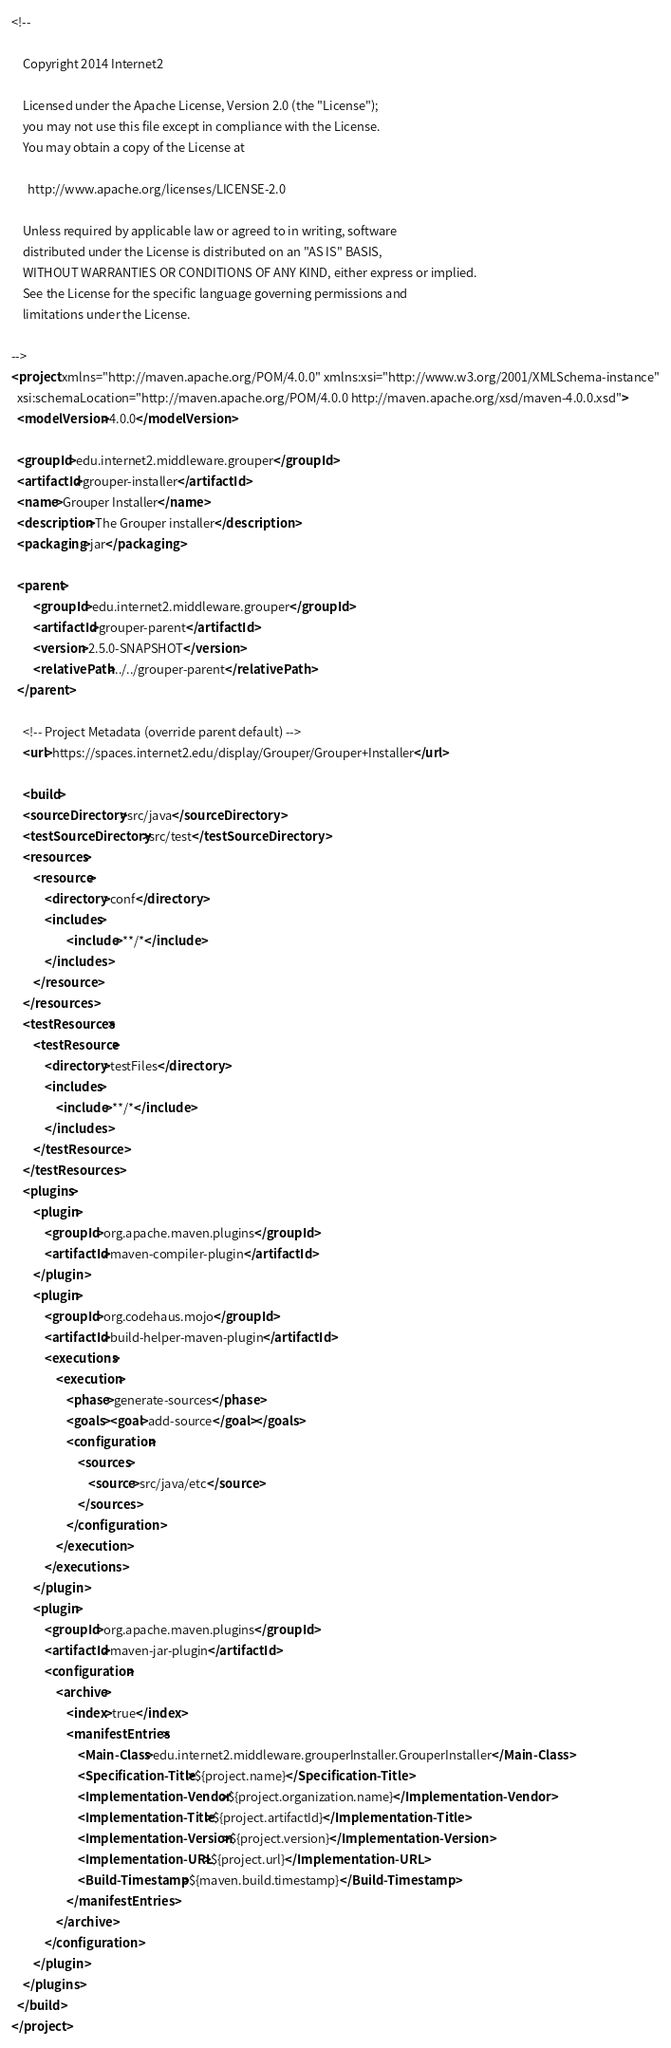Convert code to text. <code><loc_0><loc_0><loc_500><loc_500><_XML_><!--

    Copyright 2014 Internet2

    Licensed under the Apache License, Version 2.0 (the "License");
    you may not use this file except in compliance with the License.
    You may obtain a copy of the License at

      http://www.apache.org/licenses/LICENSE-2.0

    Unless required by applicable law or agreed to in writing, software
    distributed under the License is distributed on an "AS IS" BASIS,
    WITHOUT WARRANTIES OR CONDITIONS OF ANY KIND, either express or implied.
    See the License for the specific language governing permissions and
    limitations under the License.

-->
<project xmlns="http://maven.apache.org/POM/4.0.0" xmlns:xsi="http://www.w3.org/2001/XMLSchema-instance"
  xsi:schemaLocation="http://maven.apache.org/POM/4.0.0 http://maven.apache.org/xsd/maven-4.0.0.xsd">
  <modelVersion>4.0.0</modelVersion>

  <groupId>edu.internet2.middleware.grouper</groupId>
  <artifactId>grouper-installer</artifactId>
  <name>Grouper Installer</name>
  <description>The Grouper installer</description>
  <packaging>jar</packaging>
  
  <parent>
        <groupId>edu.internet2.middleware.grouper</groupId>
        <artifactId>grouper-parent</artifactId>
        <version>2.5.0-SNAPSHOT</version>
        <relativePath>../../grouper-parent</relativePath>
  </parent>

    <!-- Project Metadata (override parent default) -->
    <url>https://spaces.internet2.edu/display/Grouper/Grouper+Installer</url>

    <build>
    <sourceDirectory>src/java</sourceDirectory>
    <testSourceDirectory>src/test</testSourceDirectory>
    <resources>
        <resource>
            <directory>conf</directory>
            <includes>
                    <include>**/*</include>
            </includes>
        </resource>
    </resources>
    <testResources>
        <testResource>
            <directory>testFiles</directory>
            <includes>
                <include>**/*</include>
            </includes>
        </testResource>
    </testResources>
    <plugins>
        <plugin>
            <groupId>org.apache.maven.plugins</groupId>
            <artifactId>maven-compiler-plugin</artifactId>
        </plugin>
        <plugin>
            <groupId>org.codehaus.mojo</groupId>
            <artifactId>build-helper-maven-plugin</artifactId>
            <executions>
                <execution>
                    <phase>generate-sources</phase>
                    <goals><goal>add-source</goal></goals>
                    <configuration>
                        <sources>
                            <source>src/java/etc</source>
                        </sources>
                    </configuration>
                </execution>
            </executions>
        </plugin>
        <plugin>
            <groupId>org.apache.maven.plugins</groupId>
            <artifactId>maven-jar-plugin</artifactId>
            <configuration>
                <archive>
                    <index>true</index>
                    <manifestEntries>
                        <Main-Class>edu.internet2.middleware.grouperInstaller.GrouperInstaller</Main-Class>
                        <Specification-Title>${project.name}</Specification-Title>
                        <Implementation-Vendor>${project.organization.name}</Implementation-Vendor>
                        <Implementation-Title>${project.artifactId}</Implementation-Title>
                        <Implementation-Version>${project.version}</Implementation-Version>
                        <Implementation-URL>${project.url}</Implementation-URL>
                        <Build-Timestamp>${maven.build.timestamp}</Build-Timestamp>
                    </manifestEntries>
                </archive>
            </configuration>
        </plugin>
    </plugins>
  </build>
</project>
</code> 